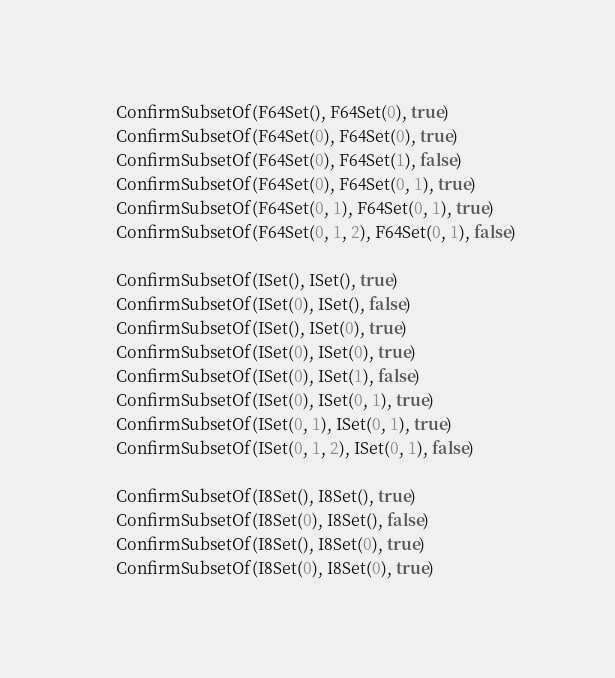Convert code to text. <code><loc_0><loc_0><loc_500><loc_500><_Go_>	ConfirmSubsetOf(F64Set(), F64Set(0), true)
	ConfirmSubsetOf(F64Set(0), F64Set(0), true)
	ConfirmSubsetOf(F64Set(0), F64Set(1), false)
	ConfirmSubsetOf(F64Set(0), F64Set(0, 1), true)
	ConfirmSubsetOf(F64Set(0, 1), F64Set(0, 1), true)
	ConfirmSubsetOf(F64Set(0, 1, 2), F64Set(0, 1), false)

	ConfirmSubsetOf(ISet(), ISet(), true)
	ConfirmSubsetOf(ISet(0), ISet(), false)
	ConfirmSubsetOf(ISet(), ISet(0), true)
	ConfirmSubsetOf(ISet(0), ISet(0), true)
	ConfirmSubsetOf(ISet(0), ISet(1), false)
	ConfirmSubsetOf(ISet(0), ISet(0, 1), true)
	ConfirmSubsetOf(ISet(0, 1), ISet(0, 1), true)
	ConfirmSubsetOf(ISet(0, 1, 2), ISet(0, 1), false)

	ConfirmSubsetOf(I8Set(), I8Set(), true)
	ConfirmSubsetOf(I8Set(0), I8Set(), false)
	ConfirmSubsetOf(I8Set(), I8Set(0), true)
	ConfirmSubsetOf(I8Set(0), I8Set(0), true)</code> 